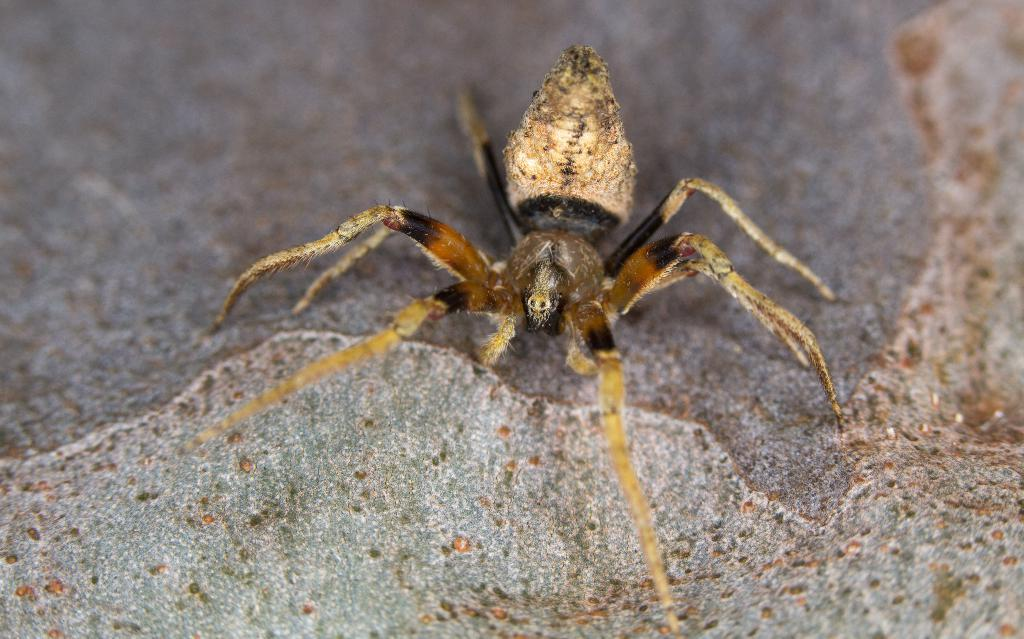What is the main subject of the image? The main subject of the image is a spider. Can you describe the spider's appearance? The spider's color is cream, black, and brown. What type of tongue does the spider have in the image? There is no information about the spider's tongue in the image, as it is not visible or mentioned in the provided facts. 